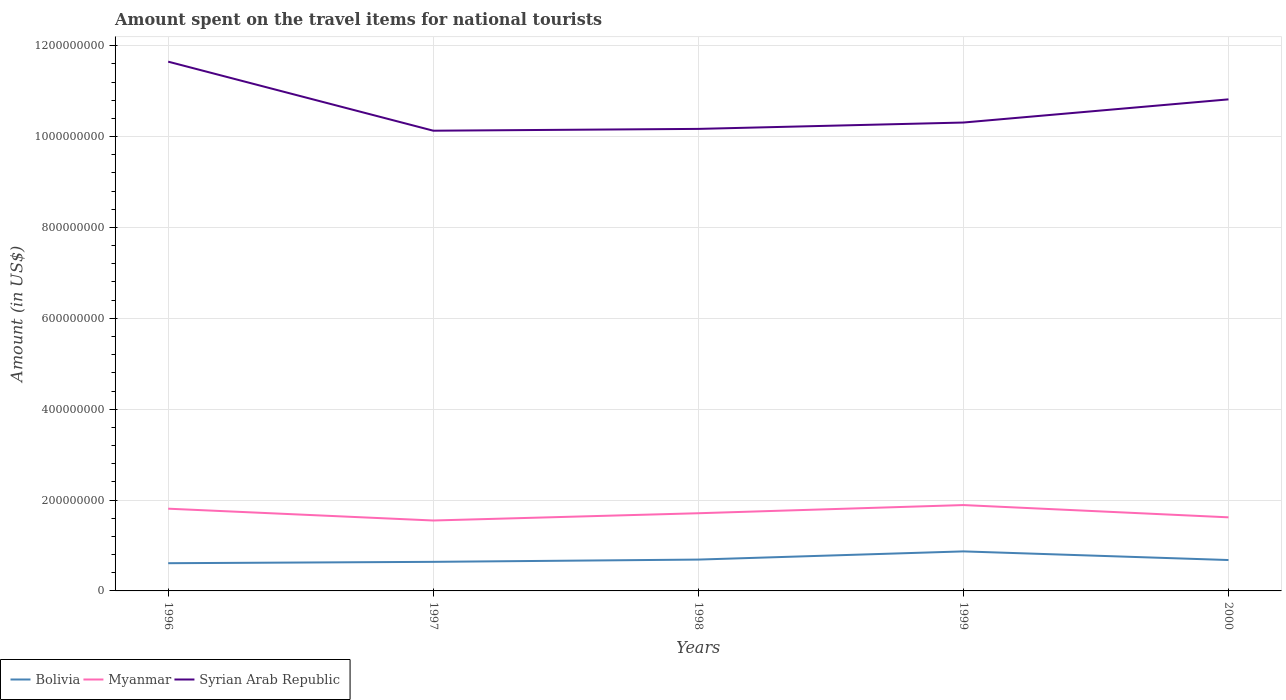How many different coloured lines are there?
Offer a very short reply. 3. Does the line corresponding to Bolivia intersect with the line corresponding to Myanmar?
Make the answer very short. No. Is the number of lines equal to the number of legend labels?
Give a very brief answer. Yes. Across all years, what is the maximum amount spent on the travel items for national tourists in Bolivia?
Your answer should be compact. 6.10e+07. What is the total amount spent on the travel items for national tourists in Syrian Arab Republic in the graph?
Make the answer very short. 8.30e+07. What is the difference between the highest and the second highest amount spent on the travel items for national tourists in Bolivia?
Offer a terse response. 2.60e+07. What is the difference between the highest and the lowest amount spent on the travel items for national tourists in Myanmar?
Provide a succinct answer. 2. Is the amount spent on the travel items for national tourists in Syrian Arab Republic strictly greater than the amount spent on the travel items for national tourists in Bolivia over the years?
Your answer should be compact. No. How many years are there in the graph?
Make the answer very short. 5. What is the difference between two consecutive major ticks on the Y-axis?
Your response must be concise. 2.00e+08. Are the values on the major ticks of Y-axis written in scientific E-notation?
Give a very brief answer. No. Does the graph contain any zero values?
Your answer should be very brief. No. How many legend labels are there?
Provide a succinct answer. 3. How are the legend labels stacked?
Make the answer very short. Horizontal. What is the title of the graph?
Provide a short and direct response. Amount spent on the travel items for national tourists. What is the label or title of the X-axis?
Your answer should be compact. Years. What is the label or title of the Y-axis?
Offer a terse response. Amount (in US$). What is the Amount (in US$) of Bolivia in 1996?
Offer a terse response. 6.10e+07. What is the Amount (in US$) in Myanmar in 1996?
Ensure brevity in your answer.  1.81e+08. What is the Amount (in US$) in Syrian Arab Republic in 1996?
Ensure brevity in your answer.  1.16e+09. What is the Amount (in US$) in Bolivia in 1997?
Keep it short and to the point. 6.40e+07. What is the Amount (in US$) of Myanmar in 1997?
Your answer should be compact. 1.55e+08. What is the Amount (in US$) in Syrian Arab Republic in 1997?
Make the answer very short. 1.01e+09. What is the Amount (in US$) of Bolivia in 1998?
Offer a very short reply. 6.90e+07. What is the Amount (in US$) in Myanmar in 1998?
Provide a short and direct response. 1.71e+08. What is the Amount (in US$) in Syrian Arab Republic in 1998?
Provide a short and direct response. 1.02e+09. What is the Amount (in US$) in Bolivia in 1999?
Your answer should be very brief. 8.70e+07. What is the Amount (in US$) in Myanmar in 1999?
Keep it short and to the point. 1.89e+08. What is the Amount (in US$) in Syrian Arab Republic in 1999?
Give a very brief answer. 1.03e+09. What is the Amount (in US$) in Bolivia in 2000?
Your answer should be very brief. 6.80e+07. What is the Amount (in US$) in Myanmar in 2000?
Keep it short and to the point. 1.62e+08. What is the Amount (in US$) in Syrian Arab Republic in 2000?
Offer a terse response. 1.08e+09. Across all years, what is the maximum Amount (in US$) in Bolivia?
Your answer should be very brief. 8.70e+07. Across all years, what is the maximum Amount (in US$) of Myanmar?
Ensure brevity in your answer.  1.89e+08. Across all years, what is the maximum Amount (in US$) in Syrian Arab Republic?
Keep it short and to the point. 1.16e+09. Across all years, what is the minimum Amount (in US$) in Bolivia?
Make the answer very short. 6.10e+07. Across all years, what is the minimum Amount (in US$) of Myanmar?
Give a very brief answer. 1.55e+08. Across all years, what is the minimum Amount (in US$) of Syrian Arab Republic?
Your answer should be compact. 1.01e+09. What is the total Amount (in US$) of Bolivia in the graph?
Give a very brief answer. 3.49e+08. What is the total Amount (in US$) in Myanmar in the graph?
Your answer should be very brief. 8.58e+08. What is the total Amount (in US$) of Syrian Arab Republic in the graph?
Give a very brief answer. 5.31e+09. What is the difference between the Amount (in US$) in Myanmar in 1996 and that in 1997?
Give a very brief answer. 2.60e+07. What is the difference between the Amount (in US$) in Syrian Arab Republic in 1996 and that in 1997?
Ensure brevity in your answer.  1.52e+08. What is the difference between the Amount (in US$) of Bolivia in 1996 and that in 1998?
Provide a short and direct response. -8.00e+06. What is the difference between the Amount (in US$) in Myanmar in 1996 and that in 1998?
Keep it short and to the point. 1.00e+07. What is the difference between the Amount (in US$) in Syrian Arab Republic in 1996 and that in 1998?
Give a very brief answer. 1.48e+08. What is the difference between the Amount (in US$) of Bolivia in 1996 and that in 1999?
Make the answer very short. -2.60e+07. What is the difference between the Amount (in US$) in Myanmar in 1996 and that in 1999?
Offer a terse response. -8.00e+06. What is the difference between the Amount (in US$) in Syrian Arab Republic in 1996 and that in 1999?
Your response must be concise. 1.34e+08. What is the difference between the Amount (in US$) of Bolivia in 1996 and that in 2000?
Offer a terse response. -7.00e+06. What is the difference between the Amount (in US$) in Myanmar in 1996 and that in 2000?
Your response must be concise. 1.90e+07. What is the difference between the Amount (in US$) of Syrian Arab Republic in 1996 and that in 2000?
Make the answer very short. 8.30e+07. What is the difference between the Amount (in US$) of Bolivia in 1997 and that in 1998?
Keep it short and to the point. -5.00e+06. What is the difference between the Amount (in US$) of Myanmar in 1997 and that in 1998?
Offer a terse response. -1.60e+07. What is the difference between the Amount (in US$) of Syrian Arab Republic in 1997 and that in 1998?
Ensure brevity in your answer.  -4.00e+06. What is the difference between the Amount (in US$) in Bolivia in 1997 and that in 1999?
Your answer should be compact. -2.30e+07. What is the difference between the Amount (in US$) in Myanmar in 1997 and that in 1999?
Provide a succinct answer. -3.40e+07. What is the difference between the Amount (in US$) of Syrian Arab Republic in 1997 and that in 1999?
Your answer should be very brief. -1.80e+07. What is the difference between the Amount (in US$) in Myanmar in 1997 and that in 2000?
Provide a short and direct response. -7.00e+06. What is the difference between the Amount (in US$) of Syrian Arab Republic in 1997 and that in 2000?
Keep it short and to the point. -6.90e+07. What is the difference between the Amount (in US$) of Bolivia in 1998 and that in 1999?
Your answer should be compact. -1.80e+07. What is the difference between the Amount (in US$) in Myanmar in 1998 and that in 1999?
Offer a terse response. -1.80e+07. What is the difference between the Amount (in US$) in Syrian Arab Republic in 1998 and that in 1999?
Offer a terse response. -1.40e+07. What is the difference between the Amount (in US$) in Myanmar in 1998 and that in 2000?
Your answer should be very brief. 9.00e+06. What is the difference between the Amount (in US$) in Syrian Arab Republic in 1998 and that in 2000?
Provide a short and direct response. -6.50e+07. What is the difference between the Amount (in US$) in Bolivia in 1999 and that in 2000?
Your answer should be very brief. 1.90e+07. What is the difference between the Amount (in US$) of Myanmar in 1999 and that in 2000?
Provide a succinct answer. 2.70e+07. What is the difference between the Amount (in US$) of Syrian Arab Republic in 1999 and that in 2000?
Offer a terse response. -5.10e+07. What is the difference between the Amount (in US$) in Bolivia in 1996 and the Amount (in US$) in Myanmar in 1997?
Your response must be concise. -9.40e+07. What is the difference between the Amount (in US$) of Bolivia in 1996 and the Amount (in US$) of Syrian Arab Republic in 1997?
Your answer should be compact. -9.52e+08. What is the difference between the Amount (in US$) of Myanmar in 1996 and the Amount (in US$) of Syrian Arab Republic in 1997?
Offer a very short reply. -8.32e+08. What is the difference between the Amount (in US$) of Bolivia in 1996 and the Amount (in US$) of Myanmar in 1998?
Your answer should be compact. -1.10e+08. What is the difference between the Amount (in US$) of Bolivia in 1996 and the Amount (in US$) of Syrian Arab Republic in 1998?
Offer a terse response. -9.56e+08. What is the difference between the Amount (in US$) in Myanmar in 1996 and the Amount (in US$) in Syrian Arab Republic in 1998?
Your response must be concise. -8.36e+08. What is the difference between the Amount (in US$) in Bolivia in 1996 and the Amount (in US$) in Myanmar in 1999?
Your answer should be very brief. -1.28e+08. What is the difference between the Amount (in US$) in Bolivia in 1996 and the Amount (in US$) in Syrian Arab Republic in 1999?
Offer a terse response. -9.70e+08. What is the difference between the Amount (in US$) of Myanmar in 1996 and the Amount (in US$) of Syrian Arab Republic in 1999?
Keep it short and to the point. -8.50e+08. What is the difference between the Amount (in US$) in Bolivia in 1996 and the Amount (in US$) in Myanmar in 2000?
Offer a terse response. -1.01e+08. What is the difference between the Amount (in US$) of Bolivia in 1996 and the Amount (in US$) of Syrian Arab Republic in 2000?
Keep it short and to the point. -1.02e+09. What is the difference between the Amount (in US$) of Myanmar in 1996 and the Amount (in US$) of Syrian Arab Republic in 2000?
Your response must be concise. -9.01e+08. What is the difference between the Amount (in US$) in Bolivia in 1997 and the Amount (in US$) in Myanmar in 1998?
Ensure brevity in your answer.  -1.07e+08. What is the difference between the Amount (in US$) in Bolivia in 1997 and the Amount (in US$) in Syrian Arab Republic in 1998?
Provide a succinct answer. -9.53e+08. What is the difference between the Amount (in US$) of Myanmar in 1997 and the Amount (in US$) of Syrian Arab Republic in 1998?
Offer a very short reply. -8.62e+08. What is the difference between the Amount (in US$) of Bolivia in 1997 and the Amount (in US$) of Myanmar in 1999?
Your response must be concise. -1.25e+08. What is the difference between the Amount (in US$) in Bolivia in 1997 and the Amount (in US$) in Syrian Arab Republic in 1999?
Keep it short and to the point. -9.67e+08. What is the difference between the Amount (in US$) of Myanmar in 1997 and the Amount (in US$) of Syrian Arab Republic in 1999?
Offer a terse response. -8.76e+08. What is the difference between the Amount (in US$) in Bolivia in 1997 and the Amount (in US$) in Myanmar in 2000?
Keep it short and to the point. -9.80e+07. What is the difference between the Amount (in US$) in Bolivia in 1997 and the Amount (in US$) in Syrian Arab Republic in 2000?
Make the answer very short. -1.02e+09. What is the difference between the Amount (in US$) in Myanmar in 1997 and the Amount (in US$) in Syrian Arab Republic in 2000?
Offer a very short reply. -9.27e+08. What is the difference between the Amount (in US$) of Bolivia in 1998 and the Amount (in US$) of Myanmar in 1999?
Your answer should be very brief. -1.20e+08. What is the difference between the Amount (in US$) in Bolivia in 1998 and the Amount (in US$) in Syrian Arab Republic in 1999?
Give a very brief answer. -9.62e+08. What is the difference between the Amount (in US$) in Myanmar in 1998 and the Amount (in US$) in Syrian Arab Republic in 1999?
Give a very brief answer. -8.60e+08. What is the difference between the Amount (in US$) of Bolivia in 1998 and the Amount (in US$) of Myanmar in 2000?
Give a very brief answer. -9.30e+07. What is the difference between the Amount (in US$) in Bolivia in 1998 and the Amount (in US$) in Syrian Arab Republic in 2000?
Your answer should be compact. -1.01e+09. What is the difference between the Amount (in US$) of Myanmar in 1998 and the Amount (in US$) of Syrian Arab Republic in 2000?
Provide a short and direct response. -9.11e+08. What is the difference between the Amount (in US$) of Bolivia in 1999 and the Amount (in US$) of Myanmar in 2000?
Offer a terse response. -7.50e+07. What is the difference between the Amount (in US$) in Bolivia in 1999 and the Amount (in US$) in Syrian Arab Republic in 2000?
Your answer should be compact. -9.95e+08. What is the difference between the Amount (in US$) of Myanmar in 1999 and the Amount (in US$) of Syrian Arab Republic in 2000?
Give a very brief answer. -8.93e+08. What is the average Amount (in US$) of Bolivia per year?
Your response must be concise. 6.98e+07. What is the average Amount (in US$) in Myanmar per year?
Provide a succinct answer. 1.72e+08. What is the average Amount (in US$) in Syrian Arab Republic per year?
Provide a succinct answer. 1.06e+09. In the year 1996, what is the difference between the Amount (in US$) in Bolivia and Amount (in US$) in Myanmar?
Provide a short and direct response. -1.20e+08. In the year 1996, what is the difference between the Amount (in US$) in Bolivia and Amount (in US$) in Syrian Arab Republic?
Ensure brevity in your answer.  -1.10e+09. In the year 1996, what is the difference between the Amount (in US$) in Myanmar and Amount (in US$) in Syrian Arab Republic?
Your answer should be compact. -9.84e+08. In the year 1997, what is the difference between the Amount (in US$) in Bolivia and Amount (in US$) in Myanmar?
Your answer should be compact. -9.10e+07. In the year 1997, what is the difference between the Amount (in US$) of Bolivia and Amount (in US$) of Syrian Arab Republic?
Your answer should be very brief. -9.49e+08. In the year 1997, what is the difference between the Amount (in US$) in Myanmar and Amount (in US$) in Syrian Arab Republic?
Provide a succinct answer. -8.58e+08. In the year 1998, what is the difference between the Amount (in US$) of Bolivia and Amount (in US$) of Myanmar?
Make the answer very short. -1.02e+08. In the year 1998, what is the difference between the Amount (in US$) in Bolivia and Amount (in US$) in Syrian Arab Republic?
Provide a succinct answer. -9.48e+08. In the year 1998, what is the difference between the Amount (in US$) of Myanmar and Amount (in US$) of Syrian Arab Republic?
Offer a very short reply. -8.46e+08. In the year 1999, what is the difference between the Amount (in US$) of Bolivia and Amount (in US$) of Myanmar?
Your answer should be very brief. -1.02e+08. In the year 1999, what is the difference between the Amount (in US$) in Bolivia and Amount (in US$) in Syrian Arab Republic?
Make the answer very short. -9.44e+08. In the year 1999, what is the difference between the Amount (in US$) in Myanmar and Amount (in US$) in Syrian Arab Republic?
Your answer should be very brief. -8.42e+08. In the year 2000, what is the difference between the Amount (in US$) of Bolivia and Amount (in US$) of Myanmar?
Keep it short and to the point. -9.40e+07. In the year 2000, what is the difference between the Amount (in US$) in Bolivia and Amount (in US$) in Syrian Arab Republic?
Keep it short and to the point. -1.01e+09. In the year 2000, what is the difference between the Amount (in US$) in Myanmar and Amount (in US$) in Syrian Arab Republic?
Your answer should be very brief. -9.20e+08. What is the ratio of the Amount (in US$) in Bolivia in 1996 to that in 1997?
Keep it short and to the point. 0.95. What is the ratio of the Amount (in US$) of Myanmar in 1996 to that in 1997?
Offer a terse response. 1.17. What is the ratio of the Amount (in US$) in Syrian Arab Republic in 1996 to that in 1997?
Your answer should be compact. 1.15. What is the ratio of the Amount (in US$) of Bolivia in 1996 to that in 1998?
Offer a very short reply. 0.88. What is the ratio of the Amount (in US$) in Myanmar in 1996 to that in 1998?
Give a very brief answer. 1.06. What is the ratio of the Amount (in US$) of Syrian Arab Republic in 1996 to that in 1998?
Your response must be concise. 1.15. What is the ratio of the Amount (in US$) in Bolivia in 1996 to that in 1999?
Provide a succinct answer. 0.7. What is the ratio of the Amount (in US$) of Myanmar in 1996 to that in 1999?
Your response must be concise. 0.96. What is the ratio of the Amount (in US$) in Syrian Arab Republic in 1996 to that in 1999?
Your answer should be compact. 1.13. What is the ratio of the Amount (in US$) of Bolivia in 1996 to that in 2000?
Provide a short and direct response. 0.9. What is the ratio of the Amount (in US$) of Myanmar in 1996 to that in 2000?
Give a very brief answer. 1.12. What is the ratio of the Amount (in US$) of Syrian Arab Republic in 1996 to that in 2000?
Provide a short and direct response. 1.08. What is the ratio of the Amount (in US$) of Bolivia in 1997 to that in 1998?
Your answer should be compact. 0.93. What is the ratio of the Amount (in US$) of Myanmar in 1997 to that in 1998?
Provide a succinct answer. 0.91. What is the ratio of the Amount (in US$) of Syrian Arab Republic in 1997 to that in 1998?
Make the answer very short. 1. What is the ratio of the Amount (in US$) of Bolivia in 1997 to that in 1999?
Give a very brief answer. 0.74. What is the ratio of the Amount (in US$) in Myanmar in 1997 to that in 1999?
Provide a succinct answer. 0.82. What is the ratio of the Amount (in US$) of Syrian Arab Republic in 1997 to that in 1999?
Ensure brevity in your answer.  0.98. What is the ratio of the Amount (in US$) in Bolivia in 1997 to that in 2000?
Offer a terse response. 0.94. What is the ratio of the Amount (in US$) in Myanmar in 1997 to that in 2000?
Provide a succinct answer. 0.96. What is the ratio of the Amount (in US$) in Syrian Arab Republic in 1997 to that in 2000?
Provide a succinct answer. 0.94. What is the ratio of the Amount (in US$) in Bolivia in 1998 to that in 1999?
Keep it short and to the point. 0.79. What is the ratio of the Amount (in US$) in Myanmar in 1998 to that in 1999?
Ensure brevity in your answer.  0.9. What is the ratio of the Amount (in US$) in Syrian Arab Republic in 1998 to that in 1999?
Keep it short and to the point. 0.99. What is the ratio of the Amount (in US$) in Bolivia in 1998 to that in 2000?
Provide a succinct answer. 1.01. What is the ratio of the Amount (in US$) of Myanmar in 1998 to that in 2000?
Provide a succinct answer. 1.06. What is the ratio of the Amount (in US$) of Syrian Arab Republic in 1998 to that in 2000?
Your response must be concise. 0.94. What is the ratio of the Amount (in US$) in Bolivia in 1999 to that in 2000?
Your answer should be compact. 1.28. What is the ratio of the Amount (in US$) of Syrian Arab Republic in 1999 to that in 2000?
Ensure brevity in your answer.  0.95. What is the difference between the highest and the second highest Amount (in US$) of Bolivia?
Make the answer very short. 1.80e+07. What is the difference between the highest and the second highest Amount (in US$) in Syrian Arab Republic?
Provide a short and direct response. 8.30e+07. What is the difference between the highest and the lowest Amount (in US$) in Bolivia?
Ensure brevity in your answer.  2.60e+07. What is the difference between the highest and the lowest Amount (in US$) in Myanmar?
Offer a very short reply. 3.40e+07. What is the difference between the highest and the lowest Amount (in US$) of Syrian Arab Republic?
Provide a succinct answer. 1.52e+08. 